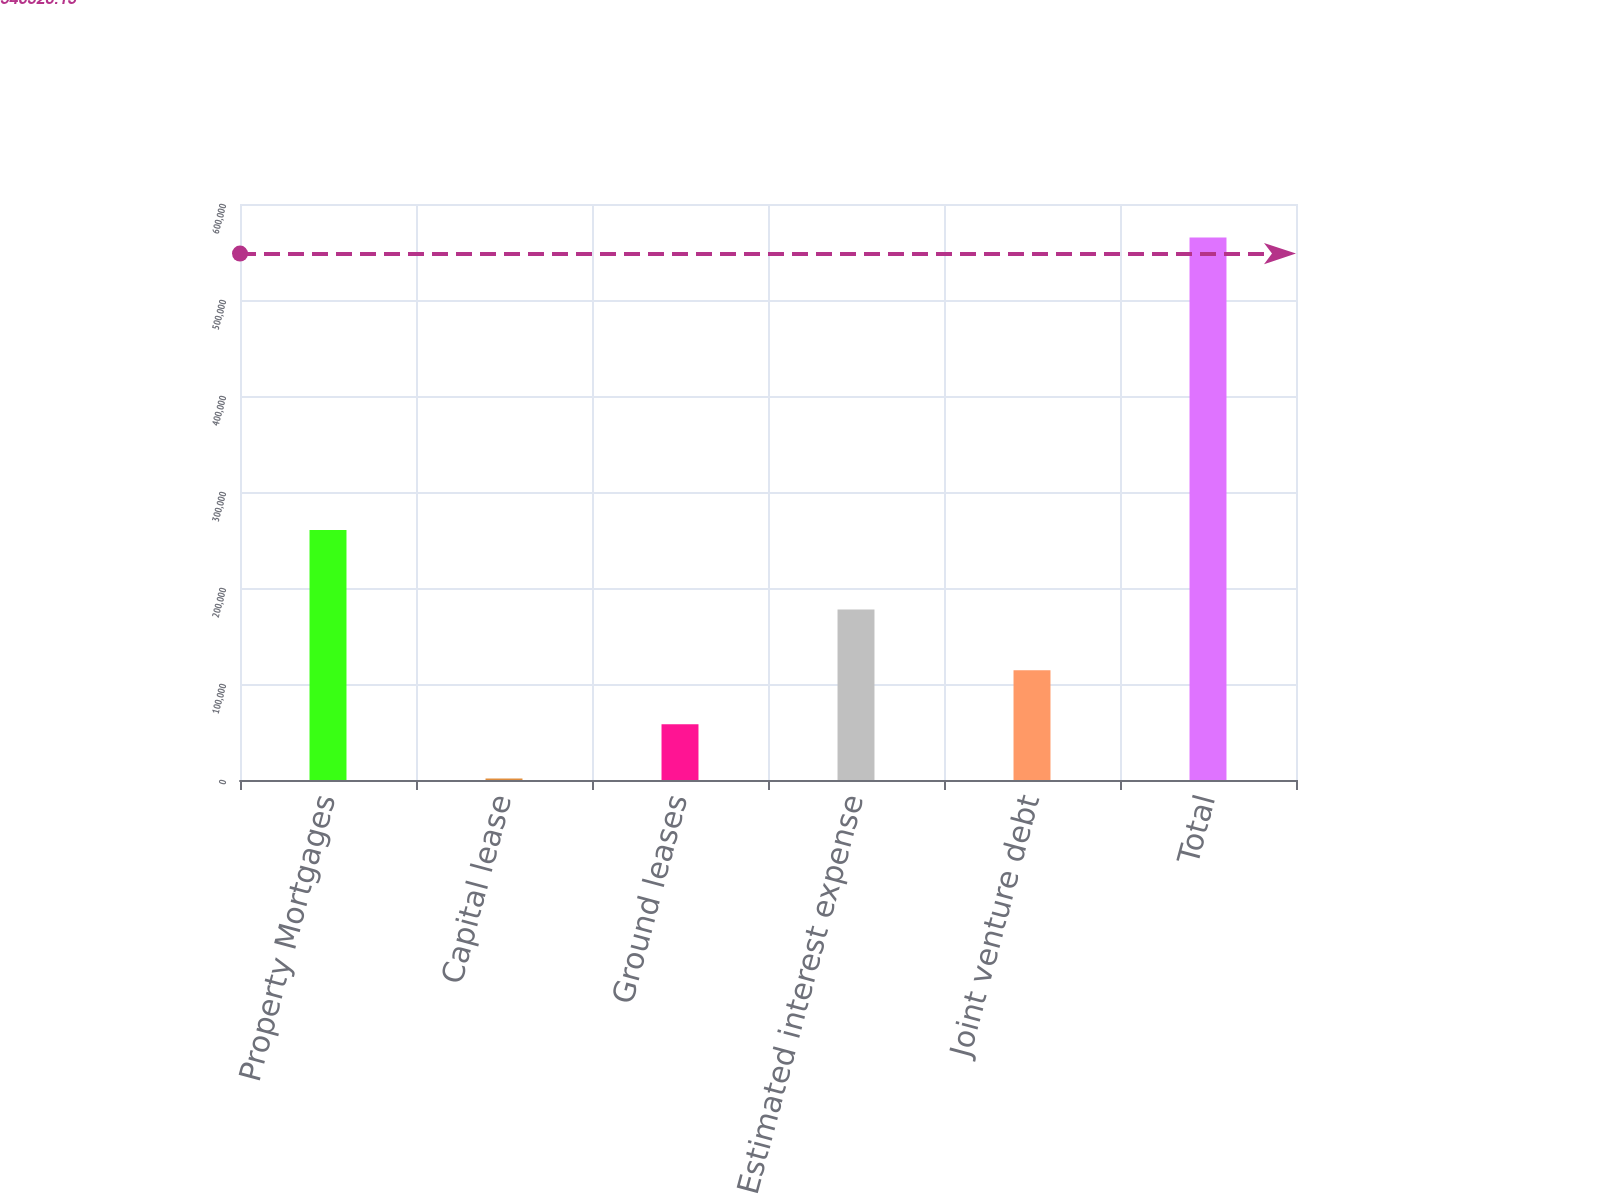Convert chart to OTSL. <chart><loc_0><loc_0><loc_500><loc_500><bar_chart><fcel>Property Mortgages<fcel>Capital lease<fcel>Ground leases<fcel>Estimated interest expense<fcel>Joint venture debt<fcel>Total<nl><fcel>260433<fcel>1593<fcel>57955<fcel>177565<fcel>114317<fcel>565213<nl></chart> 